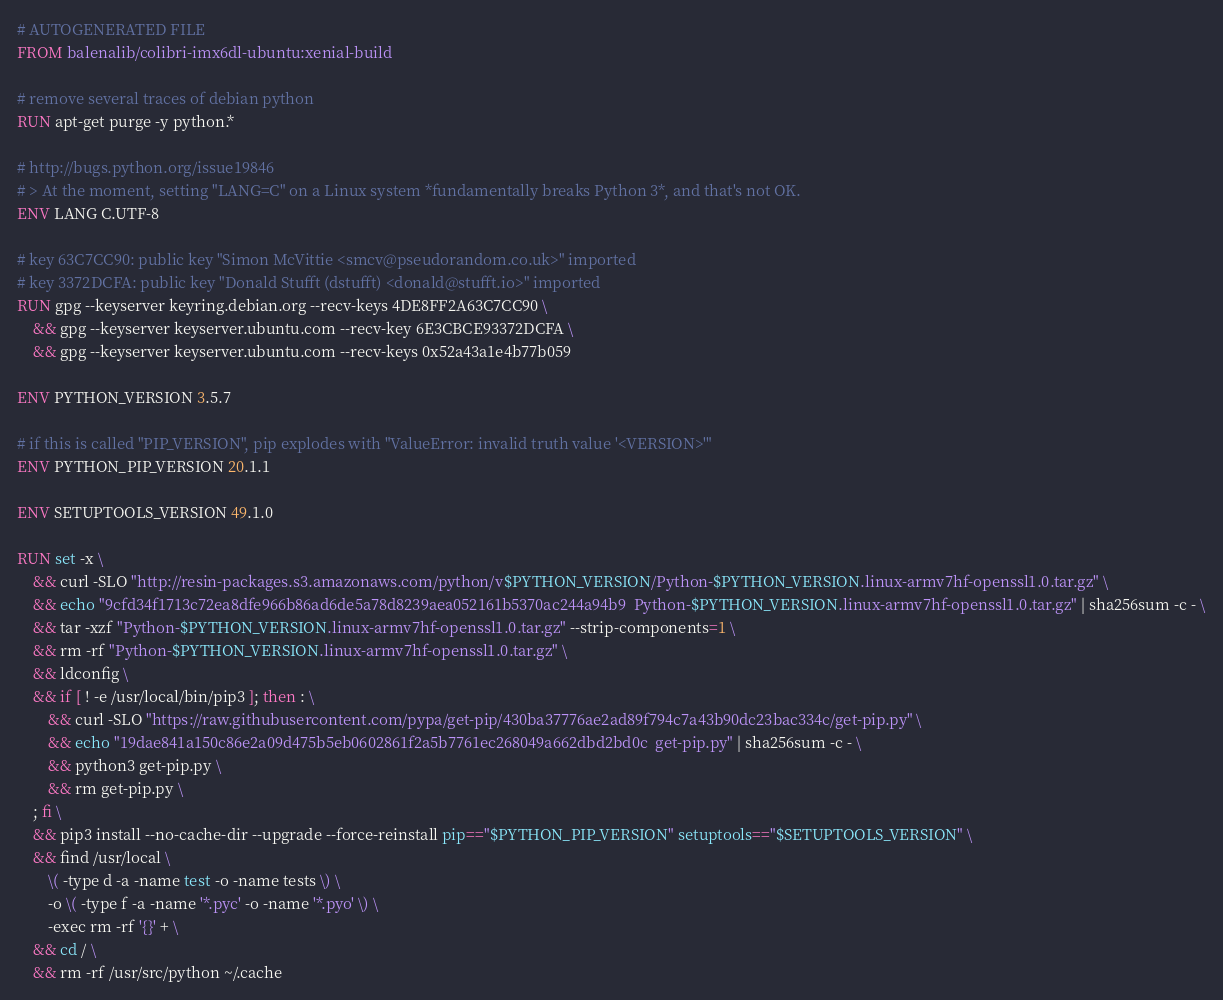<code> <loc_0><loc_0><loc_500><loc_500><_Dockerfile_># AUTOGENERATED FILE
FROM balenalib/colibri-imx6dl-ubuntu:xenial-build

# remove several traces of debian python
RUN apt-get purge -y python.*

# http://bugs.python.org/issue19846
# > At the moment, setting "LANG=C" on a Linux system *fundamentally breaks Python 3*, and that's not OK.
ENV LANG C.UTF-8

# key 63C7CC90: public key "Simon McVittie <smcv@pseudorandom.co.uk>" imported
# key 3372DCFA: public key "Donald Stufft (dstufft) <donald@stufft.io>" imported
RUN gpg --keyserver keyring.debian.org --recv-keys 4DE8FF2A63C7CC90 \
	&& gpg --keyserver keyserver.ubuntu.com --recv-key 6E3CBCE93372DCFA \
	&& gpg --keyserver keyserver.ubuntu.com --recv-keys 0x52a43a1e4b77b059

ENV PYTHON_VERSION 3.5.7

# if this is called "PIP_VERSION", pip explodes with "ValueError: invalid truth value '<VERSION>'"
ENV PYTHON_PIP_VERSION 20.1.1

ENV SETUPTOOLS_VERSION 49.1.0

RUN set -x \
	&& curl -SLO "http://resin-packages.s3.amazonaws.com/python/v$PYTHON_VERSION/Python-$PYTHON_VERSION.linux-armv7hf-openssl1.0.tar.gz" \
	&& echo "9cfd34f1713c72ea8dfe966b86ad6de5a78d8239aea052161b5370ac244a94b9  Python-$PYTHON_VERSION.linux-armv7hf-openssl1.0.tar.gz" | sha256sum -c - \
	&& tar -xzf "Python-$PYTHON_VERSION.linux-armv7hf-openssl1.0.tar.gz" --strip-components=1 \
	&& rm -rf "Python-$PYTHON_VERSION.linux-armv7hf-openssl1.0.tar.gz" \
	&& ldconfig \
	&& if [ ! -e /usr/local/bin/pip3 ]; then : \
		&& curl -SLO "https://raw.githubusercontent.com/pypa/get-pip/430ba37776ae2ad89f794c7a43b90dc23bac334c/get-pip.py" \
		&& echo "19dae841a150c86e2a09d475b5eb0602861f2a5b7761ec268049a662dbd2bd0c  get-pip.py" | sha256sum -c - \
		&& python3 get-pip.py \
		&& rm get-pip.py \
	; fi \
	&& pip3 install --no-cache-dir --upgrade --force-reinstall pip=="$PYTHON_PIP_VERSION" setuptools=="$SETUPTOOLS_VERSION" \
	&& find /usr/local \
		\( -type d -a -name test -o -name tests \) \
		-o \( -type f -a -name '*.pyc' -o -name '*.pyo' \) \
		-exec rm -rf '{}' + \
	&& cd / \
	&& rm -rf /usr/src/python ~/.cache
</code> 